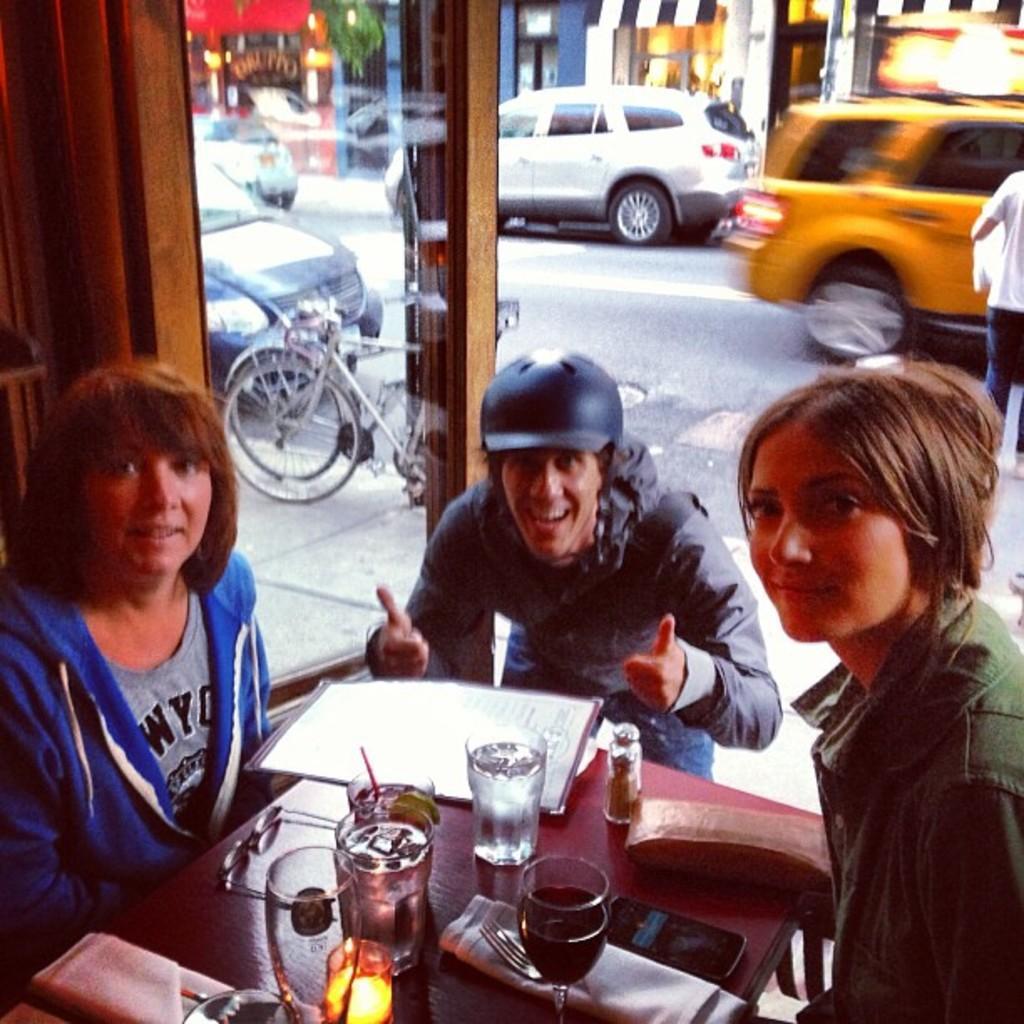Can you describe this image briefly? In this image there are three persons sitting on chairs, in the middle there is a table, on that table there are glasses, wallets and papers, in the background there is a glass wall through that wall, there are cars on road and shops are visible. 